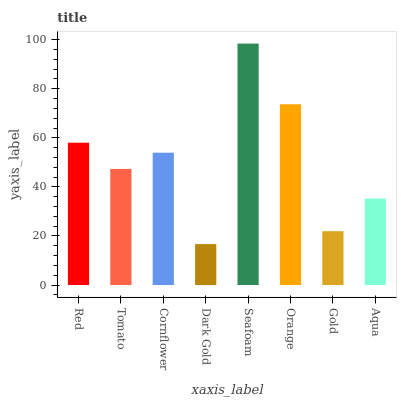Is Dark Gold the minimum?
Answer yes or no. Yes. Is Seafoam the maximum?
Answer yes or no. Yes. Is Tomato the minimum?
Answer yes or no. No. Is Tomato the maximum?
Answer yes or no. No. Is Red greater than Tomato?
Answer yes or no. Yes. Is Tomato less than Red?
Answer yes or no. Yes. Is Tomato greater than Red?
Answer yes or no. No. Is Red less than Tomato?
Answer yes or no. No. Is Cornflower the high median?
Answer yes or no. Yes. Is Tomato the low median?
Answer yes or no. Yes. Is Red the high median?
Answer yes or no. No. Is Red the low median?
Answer yes or no. No. 